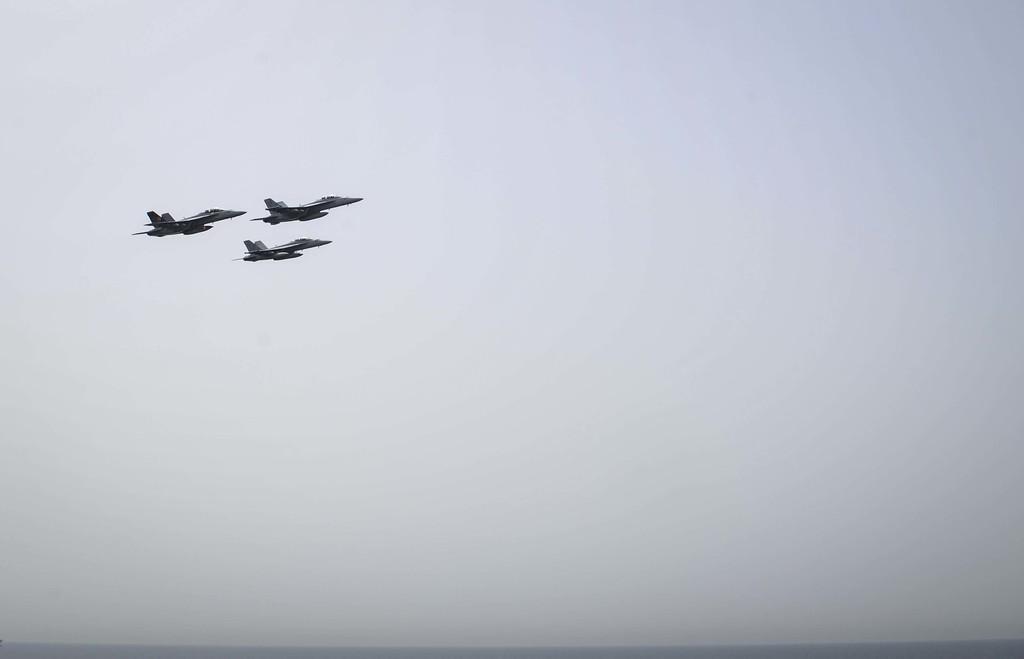Please provide a concise description of this image. In the image there are three planes flying in the sky. 